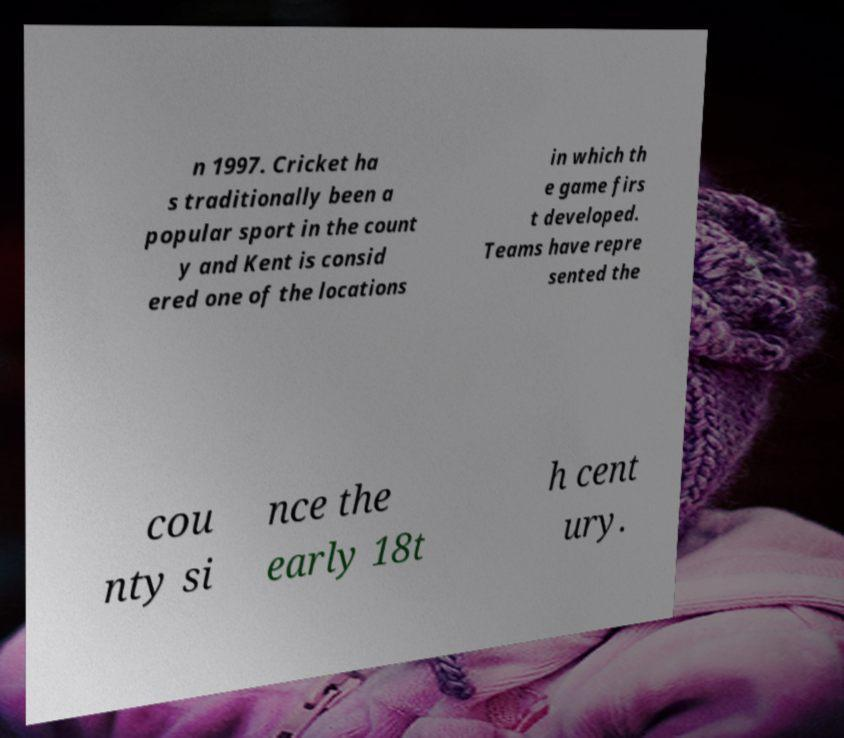Could you extract and type out the text from this image? n 1997. Cricket ha s traditionally been a popular sport in the count y and Kent is consid ered one of the locations in which th e game firs t developed. Teams have repre sented the cou nty si nce the early 18t h cent ury. 